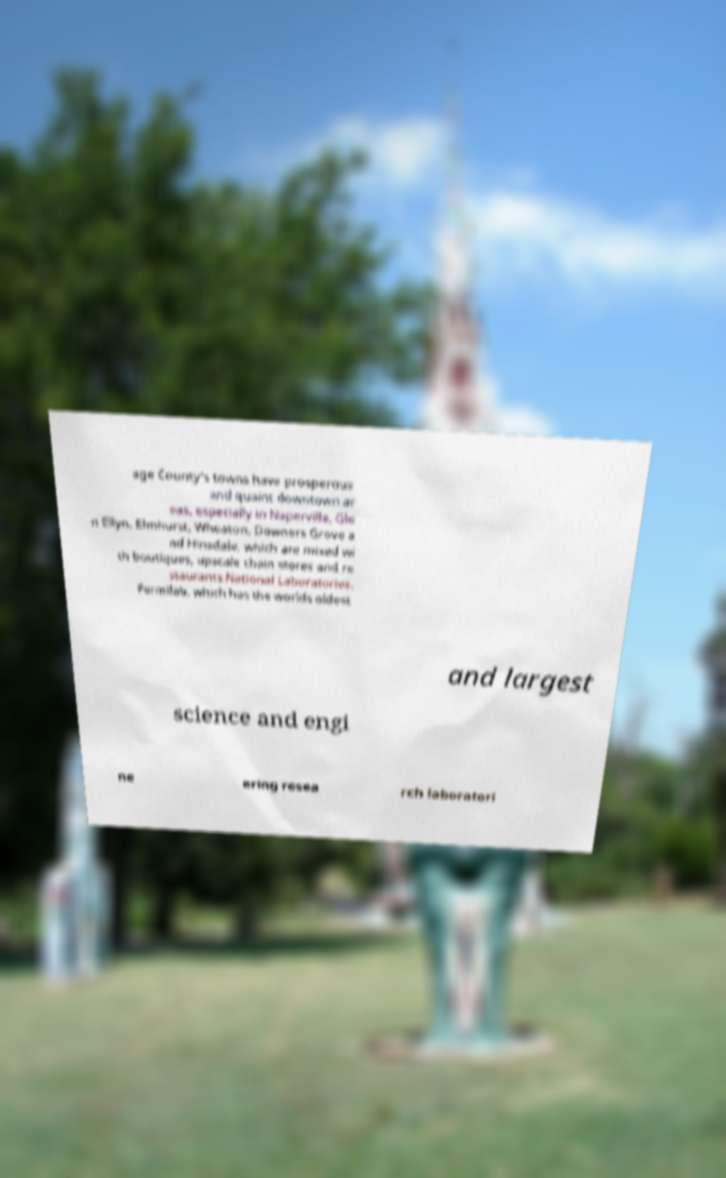I need the written content from this picture converted into text. Can you do that? age County's towns have prosperous and quaint downtown ar eas, especially in Naperville, Gle n Ellyn, Elmhurst, Wheaton, Downers Grove a nd Hinsdale, which are mixed wi th boutiques, upscale chain stores and re staurants.National Laboratories. Fermilab, which has the worlds oldest and largest science and engi ne ering resea rch laboratori 